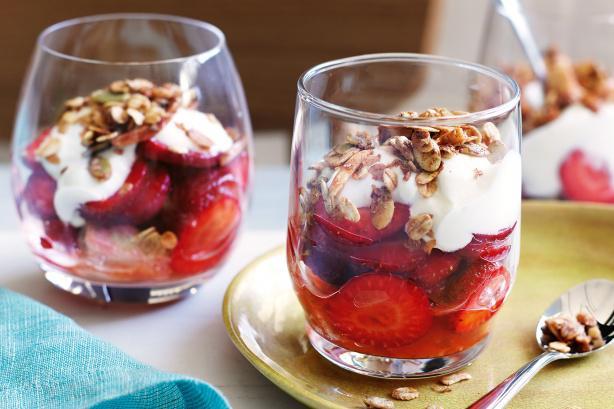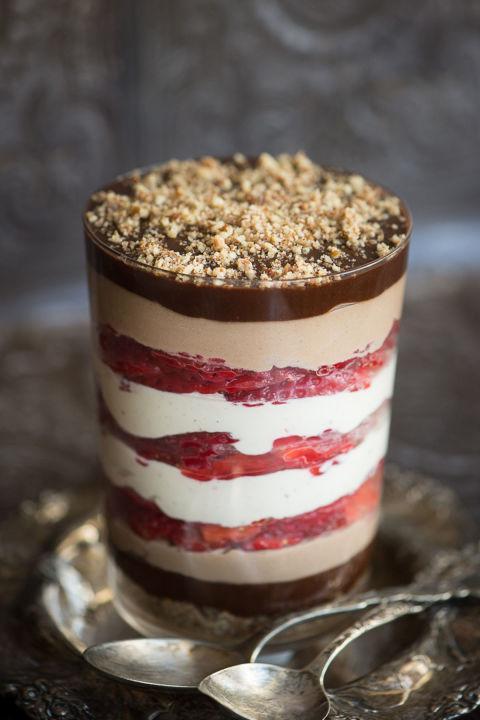The first image is the image on the left, the second image is the image on the right. For the images shown, is this caption "An image shows side-by-side desserts with blueberries around the rim." true? Answer yes or no. No. 